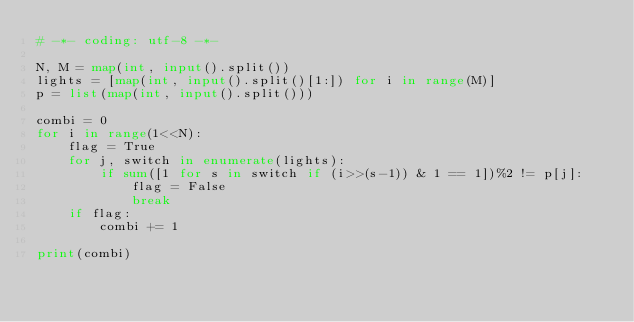<code> <loc_0><loc_0><loc_500><loc_500><_Python_># -*- coding: utf-8 -*-

N, M = map(int, input().split())
lights = [map(int, input().split()[1:]) for i in range(M)]
p = list(map(int, input().split()))

combi = 0
for i in range(1<<N):
    flag = True
    for j, switch in enumerate(lights):
        if sum([1 for s in switch if (i>>(s-1)) & 1 == 1])%2 != p[j]:
            flag = False
            break
    if flag:
        combi += 1

print(combi)</code> 